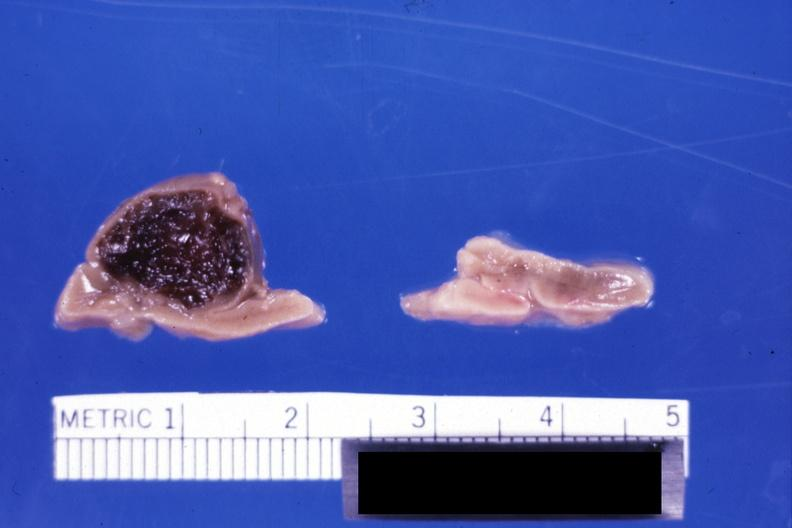where does this belong to?
Answer the question using a single word or phrase. Endocrine system 